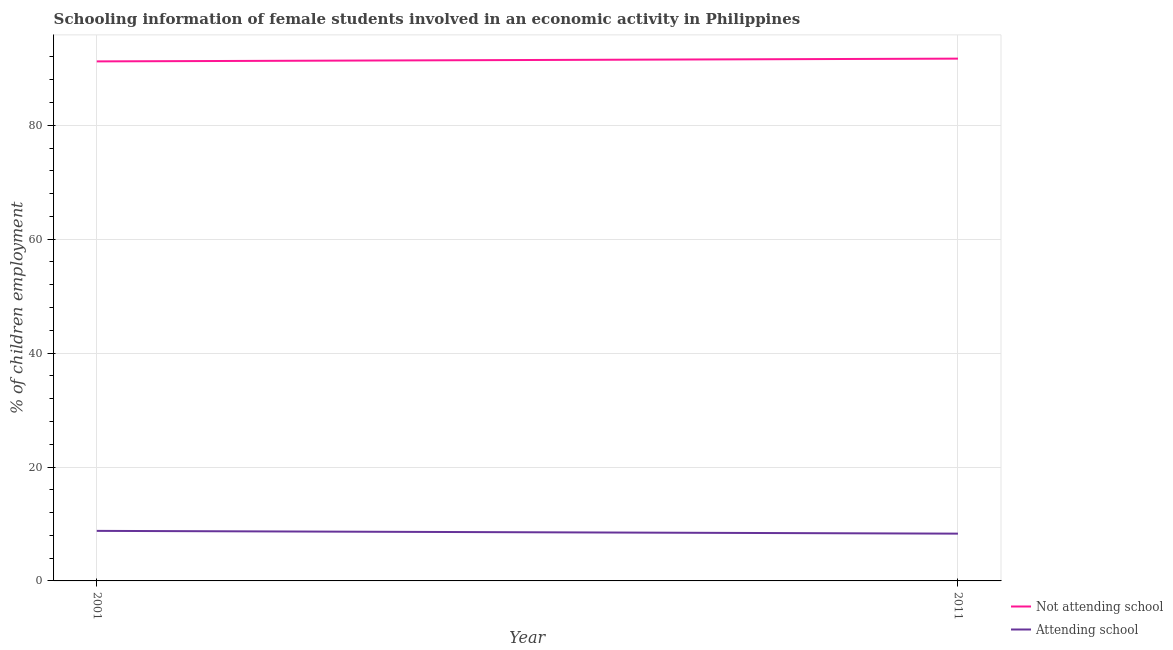Is the number of lines equal to the number of legend labels?
Offer a terse response. Yes. Across all years, what is the maximum percentage of employed females who are not attending school?
Keep it short and to the point. 91.7. In which year was the percentage of employed females who are not attending school minimum?
Ensure brevity in your answer.  2001. What is the total percentage of employed females who are not attending school in the graph?
Give a very brief answer. 182.91. What is the difference between the percentage of employed females who are not attending school in 2001 and that in 2011?
Offer a terse response. -0.49. What is the difference between the percentage of employed females who are attending school in 2011 and the percentage of employed females who are not attending school in 2001?
Offer a terse response. -82.91. What is the average percentage of employed females who are attending school per year?
Make the answer very short. 8.54. In the year 2011, what is the difference between the percentage of employed females who are not attending school and percentage of employed females who are attending school?
Keep it short and to the point. 83.4. What is the ratio of the percentage of employed females who are not attending school in 2001 to that in 2011?
Offer a very short reply. 0.99. In how many years, is the percentage of employed females who are not attending school greater than the average percentage of employed females who are not attending school taken over all years?
Make the answer very short. 1. Is the percentage of employed females who are not attending school strictly greater than the percentage of employed females who are attending school over the years?
Provide a short and direct response. Yes. How many years are there in the graph?
Offer a terse response. 2. What is the difference between two consecutive major ticks on the Y-axis?
Keep it short and to the point. 20. Does the graph contain any zero values?
Keep it short and to the point. No. Does the graph contain grids?
Provide a succinct answer. Yes. How many legend labels are there?
Offer a very short reply. 2. What is the title of the graph?
Ensure brevity in your answer.  Schooling information of female students involved in an economic activity in Philippines. What is the label or title of the Y-axis?
Make the answer very short. % of children employment. What is the % of children employment of Not attending school in 2001?
Offer a terse response. 91.21. What is the % of children employment in Attending school in 2001?
Provide a succinct answer. 8.79. What is the % of children employment in Not attending school in 2011?
Provide a succinct answer. 91.7. Across all years, what is the maximum % of children employment in Not attending school?
Provide a succinct answer. 91.7. Across all years, what is the maximum % of children employment in Attending school?
Your answer should be very brief. 8.79. Across all years, what is the minimum % of children employment of Not attending school?
Keep it short and to the point. 91.21. Across all years, what is the minimum % of children employment in Attending school?
Ensure brevity in your answer.  8.3. What is the total % of children employment of Not attending school in the graph?
Make the answer very short. 182.91. What is the total % of children employment in Attending school in the graph?
Give a very brief answer. 17.09. What is the difference between the % of children employment of Not attending school in 2001 and that in 2011?
Your response must be concise. -0.49. What is the difference between the % of children employment in Attending school in 2001 and that in 2011?
Offer a terse response. 0.49. What is the difference between the % of children employment of Not attending school in 2001 and the % of children employment of Attending school in 2011?
Offer a terse response. 82.91. What is the average % of children employment in Not attending school per year?
Give a very brief answer. 91.46. What is the average % of children employment in Attending school per year?
Your response must be concise. 8.54. In the year 2001, what is the difference between the % of children employment of Not attending school and % of children employment of Attending school?
Provide a short and direct response. 82.43. In the year 2011, what is the difference between the % of children employment in Not attending school and % of children employment in Attending school?
Your answer should be very brief. 83.4. What is the ratio of the % of children employment in Attending school in 2001 to that in 2011?
Provide a short and direct response. 1.06. What is the difference between the highest and the second highest % of children employment of Not attending school?
Give a very brief answer. 0.49. What is the difference between the highest and the second highest % of children employment in Attending school?
Give a very brief answer. 0.49. What is the difference between the highest and the lowest % of children employment of Not attending school?
Give a very brief answer. 0.49. What is the difference between the highest and the lowest % of children employment of Attending school?
Make the answer very short. 0.49. 